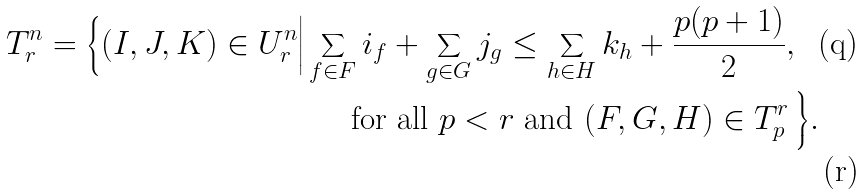<formula> <loc_0><loc_0><loc_500><loc_500>T ^ { n } _ { r } = \Big \{ ( I , J , K ) \in U ^ { n } _ { r } \Big | \sum _ { f \in F } i _ { f } + \sum _ { g \in G } j _ { g } \leq \sum _ { h \in H } k _ { h } + \frac { p ( p + 1 ) } 2 , & \\ \text { for all } p < r \text { and } ( F , G , H ) \in T ^ { r } _ { p } \, & \Big \} .</formula> 